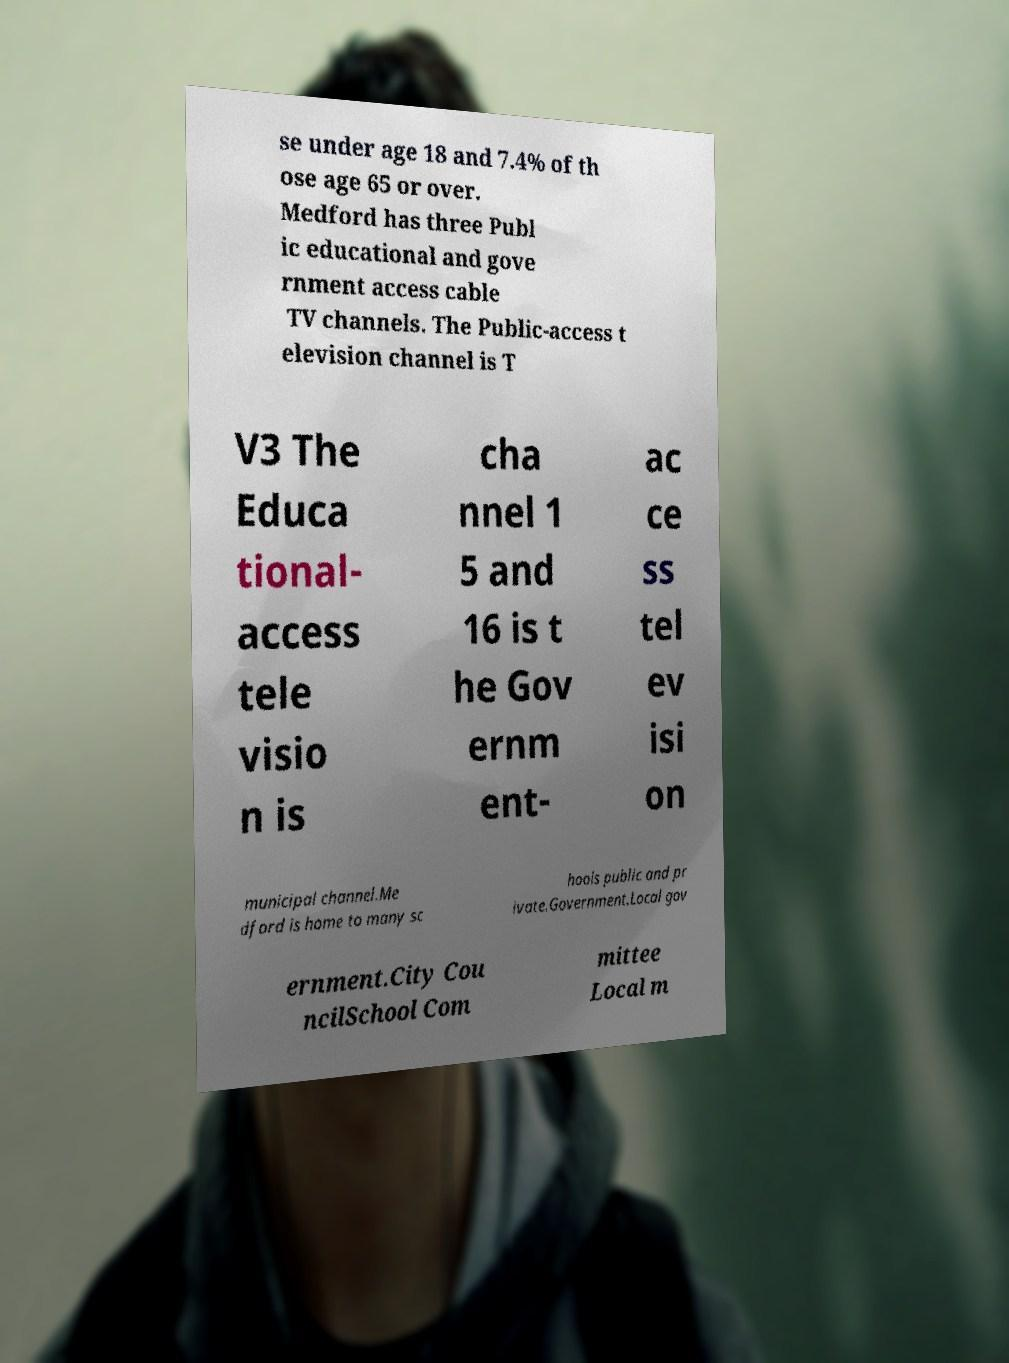There's text embedded in this image that I need extracted. Can you transcribe it verbatim? se under age 18 and 7.4% of th ose age 65 or over. Medford has three Publ ic educational and gove rnment access cable TV channels. The Public-access t elevision channel is T V3 The Educa tional- access tele visio n is cha nnel 1 5 and 16 is t he Gov ernm ent- ac ce ss tel ev isi on municipal channel.Me dford is home to many sc hools public and pr ivate.Government.Local gov ernment.City Cou ncilSchool Com mittee Local m 